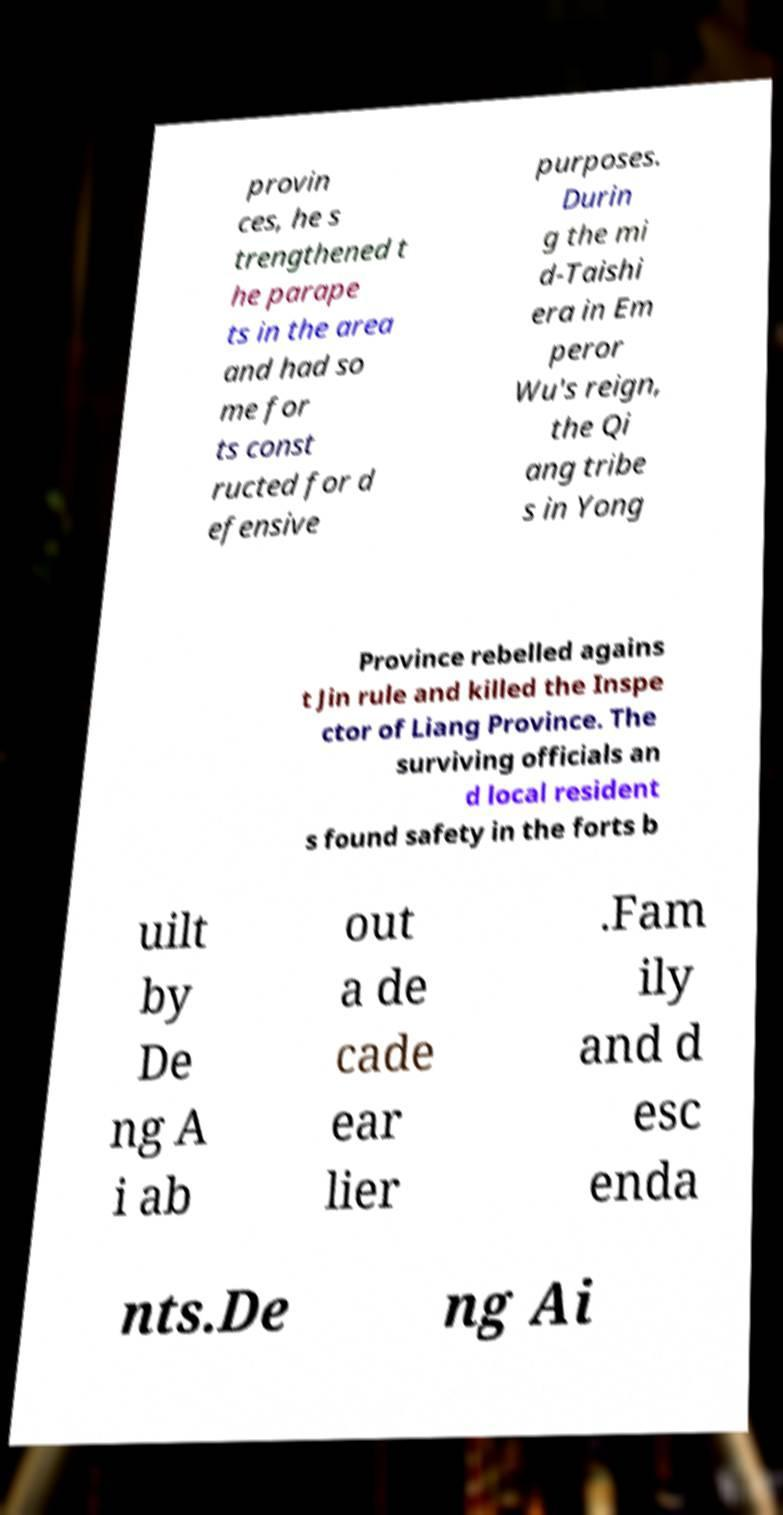Please identify and transcribe the text found in this image. provin ces, he s trengthened t he parape ts in the area and had so me for ts const ructed for d efensive purposes. Durin g the mi d-Taishi era in Em peror Wu's reign, the Qi ang tribe s in Yong Province rebelled agains t Jin rule and killed the Inspe ctor of Liang Province. The surviving officials an d local resident s found safety in the forts b uilt by De ng A i ab out a de cade ear lier .Fam ily and d esc enda nts.De ng Ai 